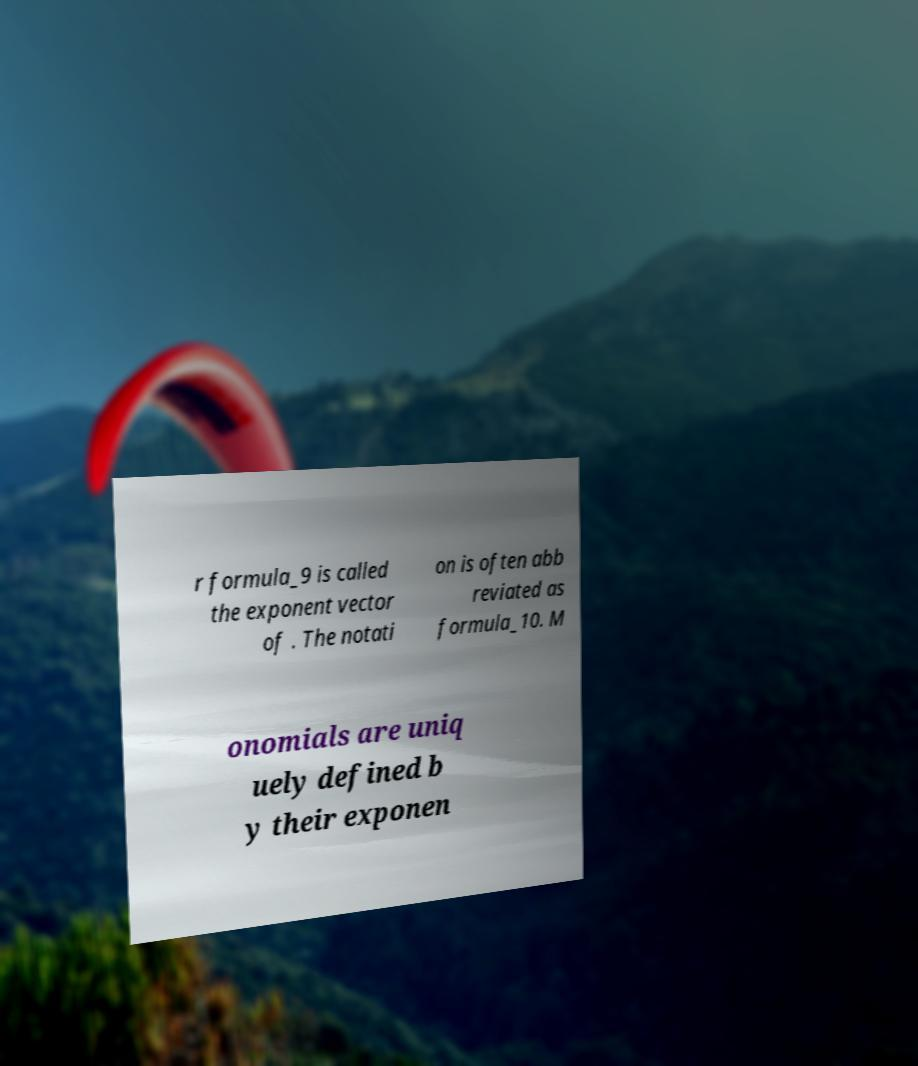There's text embedded in this image that I need extracted. Can you transcribe it verbatim? r formula_9 is called the exponent vector of . The notati on is often abb reviated as formula_10. M onomials are uniq uely defined b y their exponen 